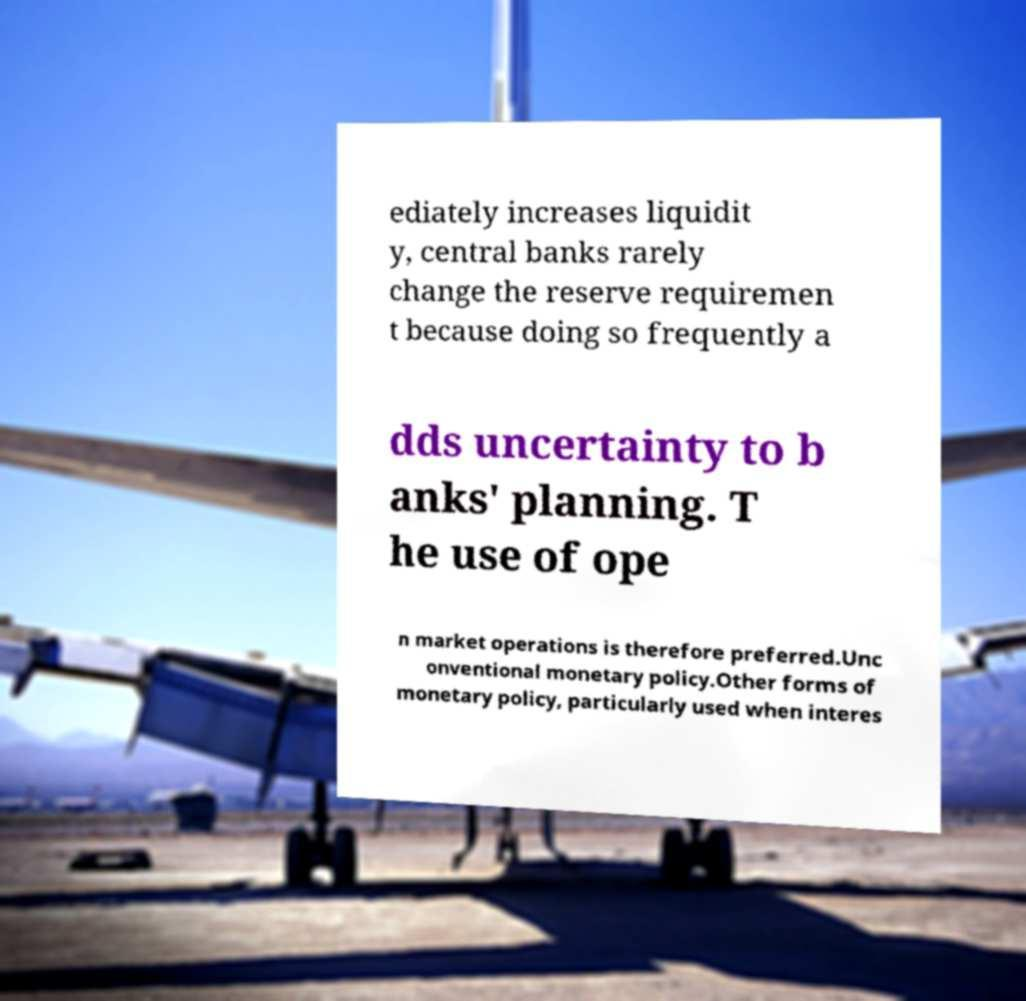Can you read and provide the text displayed in the image?This photo seems to have some interesting text. Can you extract and type it out for me? ediately increases liquidit y, central banks rarely change the reserve requiremen t because doing so frequently a dds uncertainty to b anks' planning. T he use of ope n market operations is therefore preferred.Unc onventional monetary policy.Other forms of monetary policy, particularly used when interes 